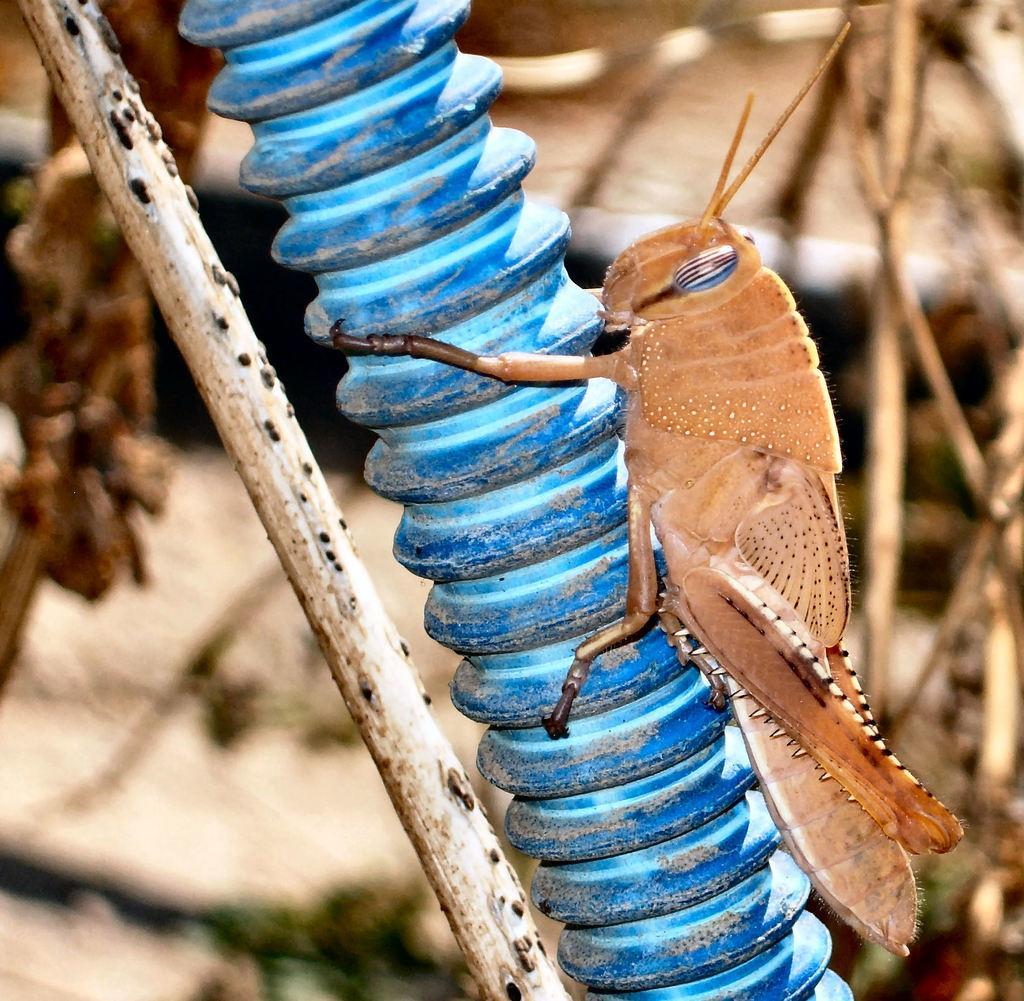Can you describe this image briefly? The picture consists of a grasshopper on a pipe. Towards left there is a stick. The background is blurred. In the background there are twigs. 